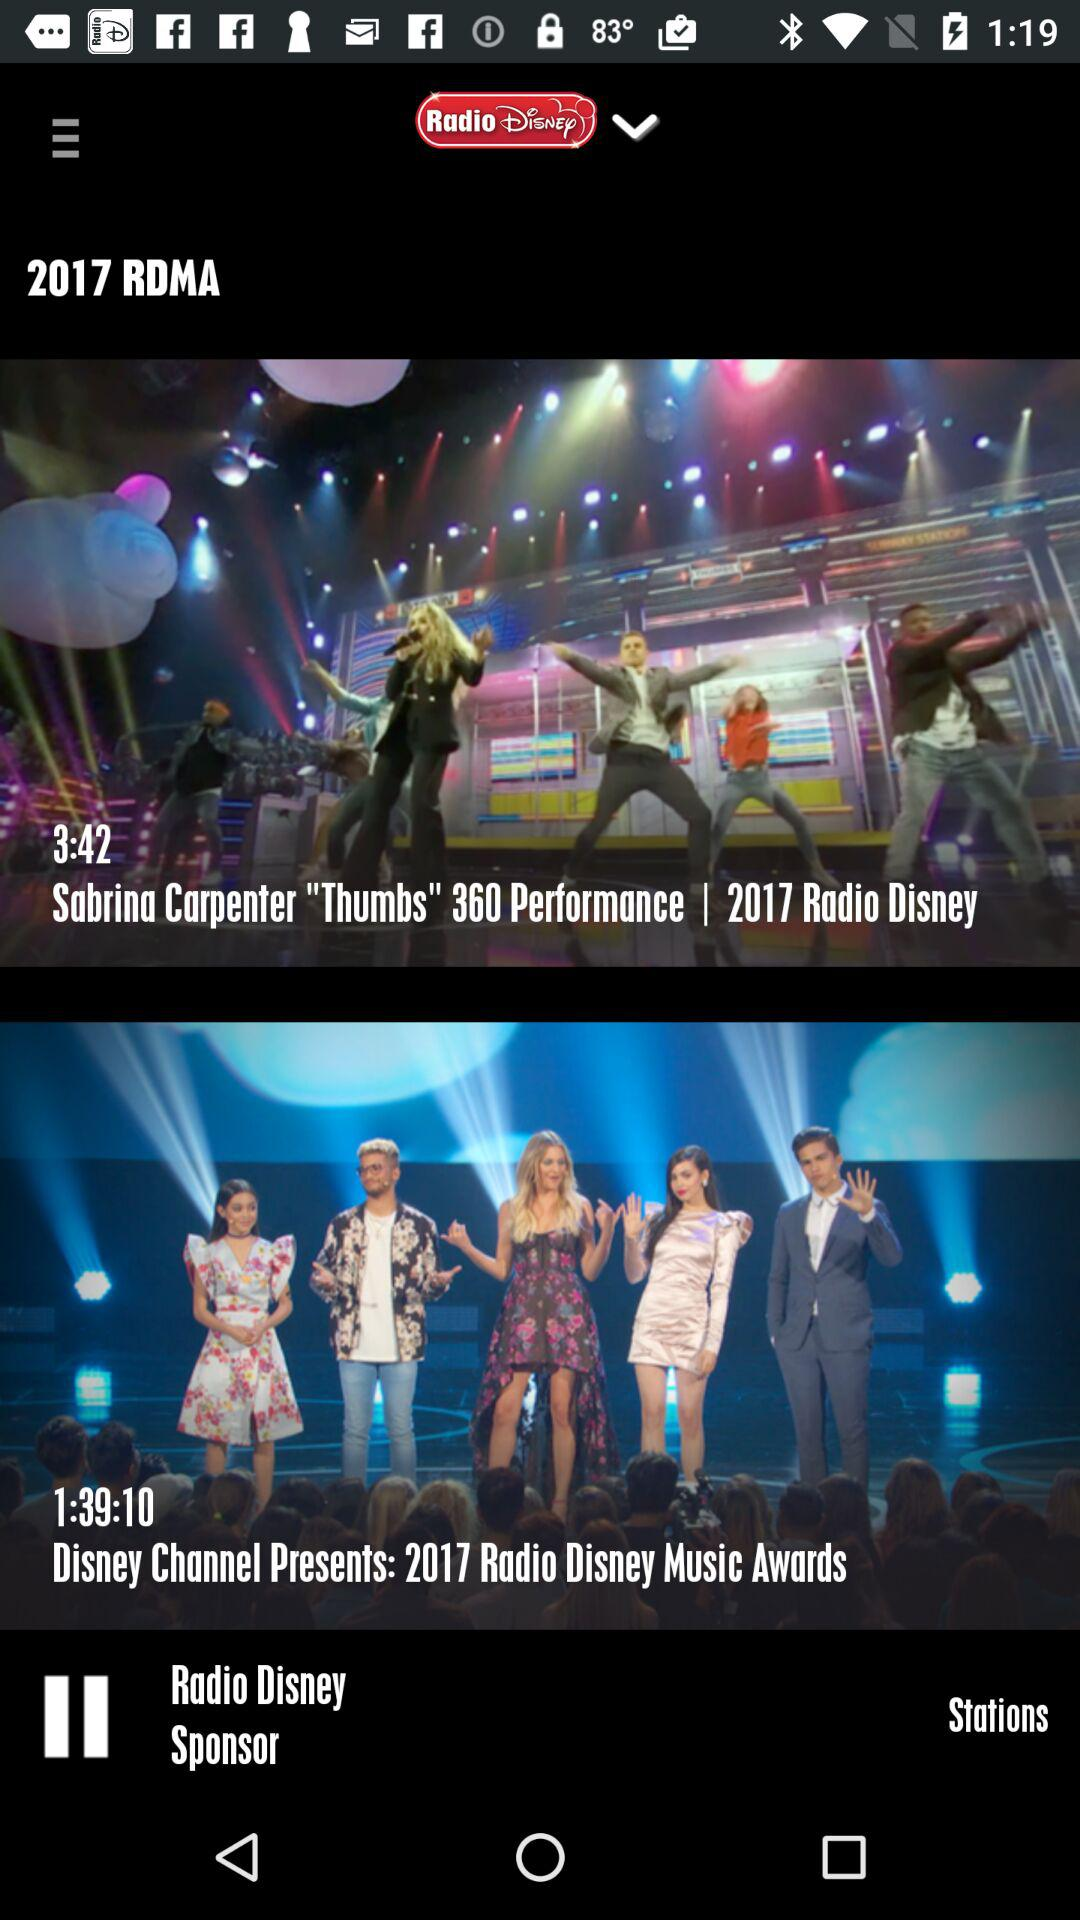What is the duration of the video "Sabrina Carpenter "Thumbs" 360 Performance"? The duration of the video "Sabrina Carpenter "Thumbs" 360 Performance" is 3 minutes and 42 seconds. 